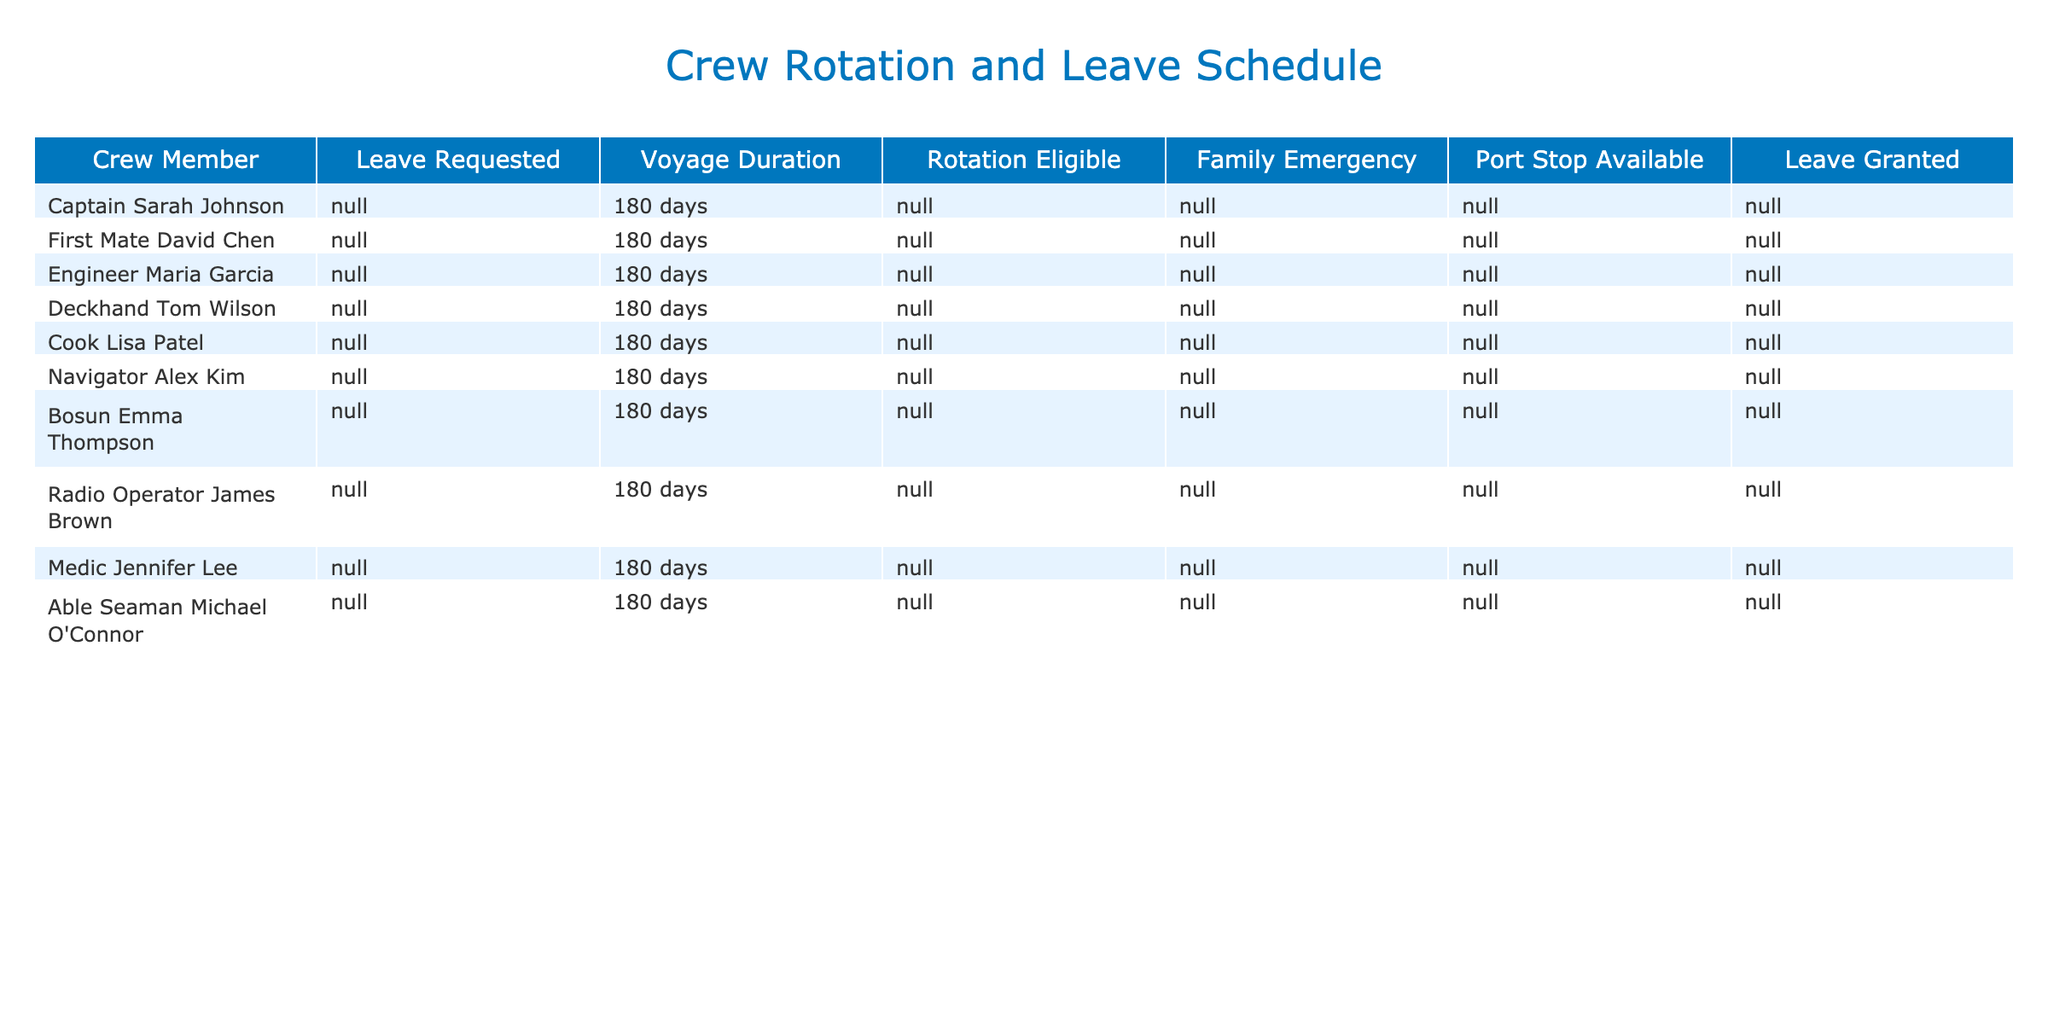What percentage of crew members requested leave? There are 10 crew members in total, and 5 of them requested leave. To find the percentage, we calculate (5/10) * 100 = 50%.
Answer: 50% Is Engineer Maria Garcia's leave status 'Granted'? From the table, Engineer Maria Garcia requested leave and it was granted.
Answer: Yes How many crew members are eligible for rotation but did not request leave? There are 4 crew members eligible for rotation: First Mate David Chen, Bosun Emma Thompson, Medic Jennifer Lee, and Engineer Maria Garcia. Out of these, only David and Emma did not request leave. That gives us a total of 2 crew members.
Answer: 2 Which crew member has a family emergency and was granted leave? The table shows that Medic Jennifer Lee has a family emergency, and her leave was granted.
Answer: Medic Jennifer Lee What is the total number of crew members who either requested leave or have a family emergency? First, we identify the crew members who requested leave: 5 members (Engineer Maria Garcia, Deckhand Tom Wilson, Navigator Alex Kim, Radio Operator James Brown, Able Seaman Michael O'Connor). Next, we check the family emergencies: only Medic Jennifer Lee and Deckhand Tom Wilson have family emergencies. Since Tom Wilson is already counted, we add Medic Jennifer Lee, giving us a total of 6 unique crew members.
Answer: 6 